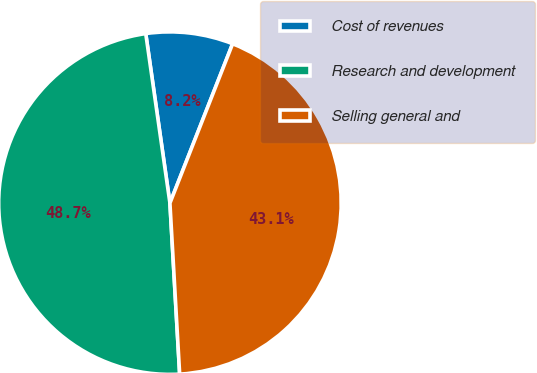Convert chart. <chart><loc_0><loc_0><loc_500><loc_500><pie_chart><fcel>Cost of revenues<fcel>Research and development<fcel>Selling general and<nl><fcel>8.22%<fcel>48.65%<fcel>43.13%<nl></chart> 